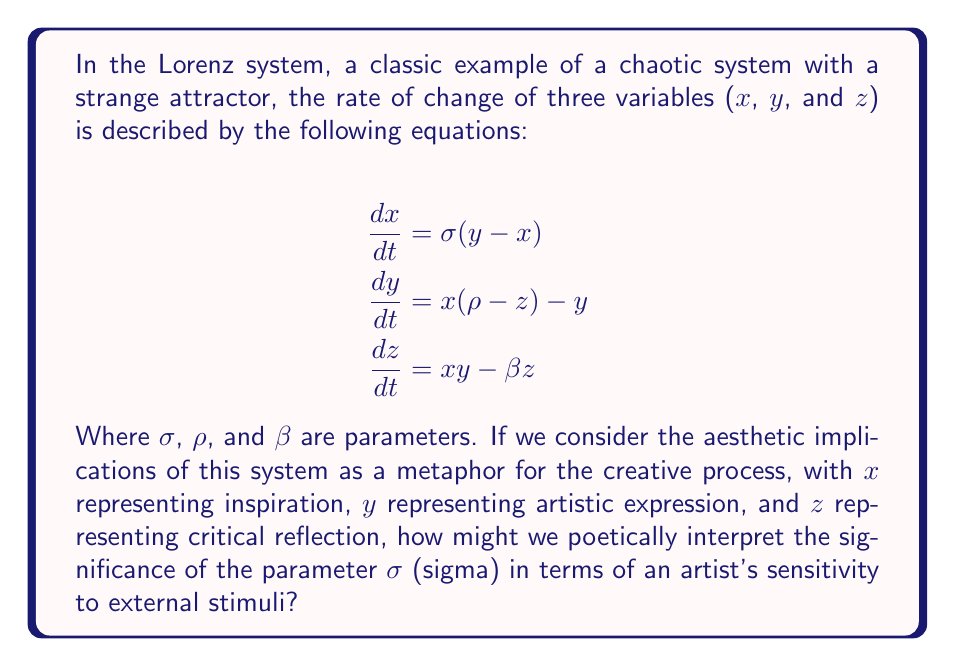Provide a solution to this math problem. To answer this question, we need to understand the role of σ in the Lorenz system and then interpret it in the context of the artistic process:

1. In the Lorenz system, σ appears in the first equation:
   $$\frac{dx}{dt} = \sigma(y - x)$$

2. This equation describes the rate of change of x (inspiration) based on the difference between y (artistic expression) and x, multiplied by σ.

3. σ is often called the Prandtl number and typically has a value around 10 in atmospheric models.

4. A larger σ means that x responds more quickly to differences between x and y.

5. In our artistic metaphor:
   - x represents inspiration
   - y represents artistic expression
   - σ can be interpreted as the artist's sensitivity to the gap between their current inspiration and their ability to express it

6. A higher σ would mean the artist's inspiration (x) changes more rapidly in response to differences between their current inspiration and their artistic expression.

7. Poetically, we can interpret σ as the artist's sensitivity to external stimuli and internal creative tensions.

8. A higher σ might represent an artist who is more responsive to their environment and quicker to find new inspiration when their current expression doesn't match their vision.

9. Conversely, a lower σ could represent an artist who is less easily swayed by external influences and maintains a more consistent internal creative state.

10. The chaotic nature of the system suggests that even small changes in σ can lead to dramatically different creative trajectories over time, highlighting the delicate balance in the artistic process.
Answer: σ represents the artist's sensitivity to the discrepancy between inspiration and expression, influencing the rate of creative adaptation. 